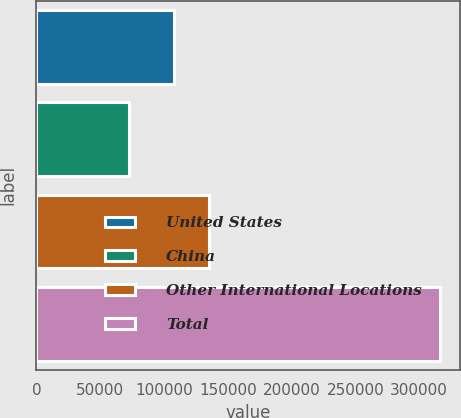<chart> <loc_0><loc_0><loc_500><loc_500><bar_chart><fcel>United States<fcel>China<fcel>Other International Locations<fcel>Total<nl><fcel>108223<fcel>72489<fcel>135482<fcel>316194<nl></chart> 